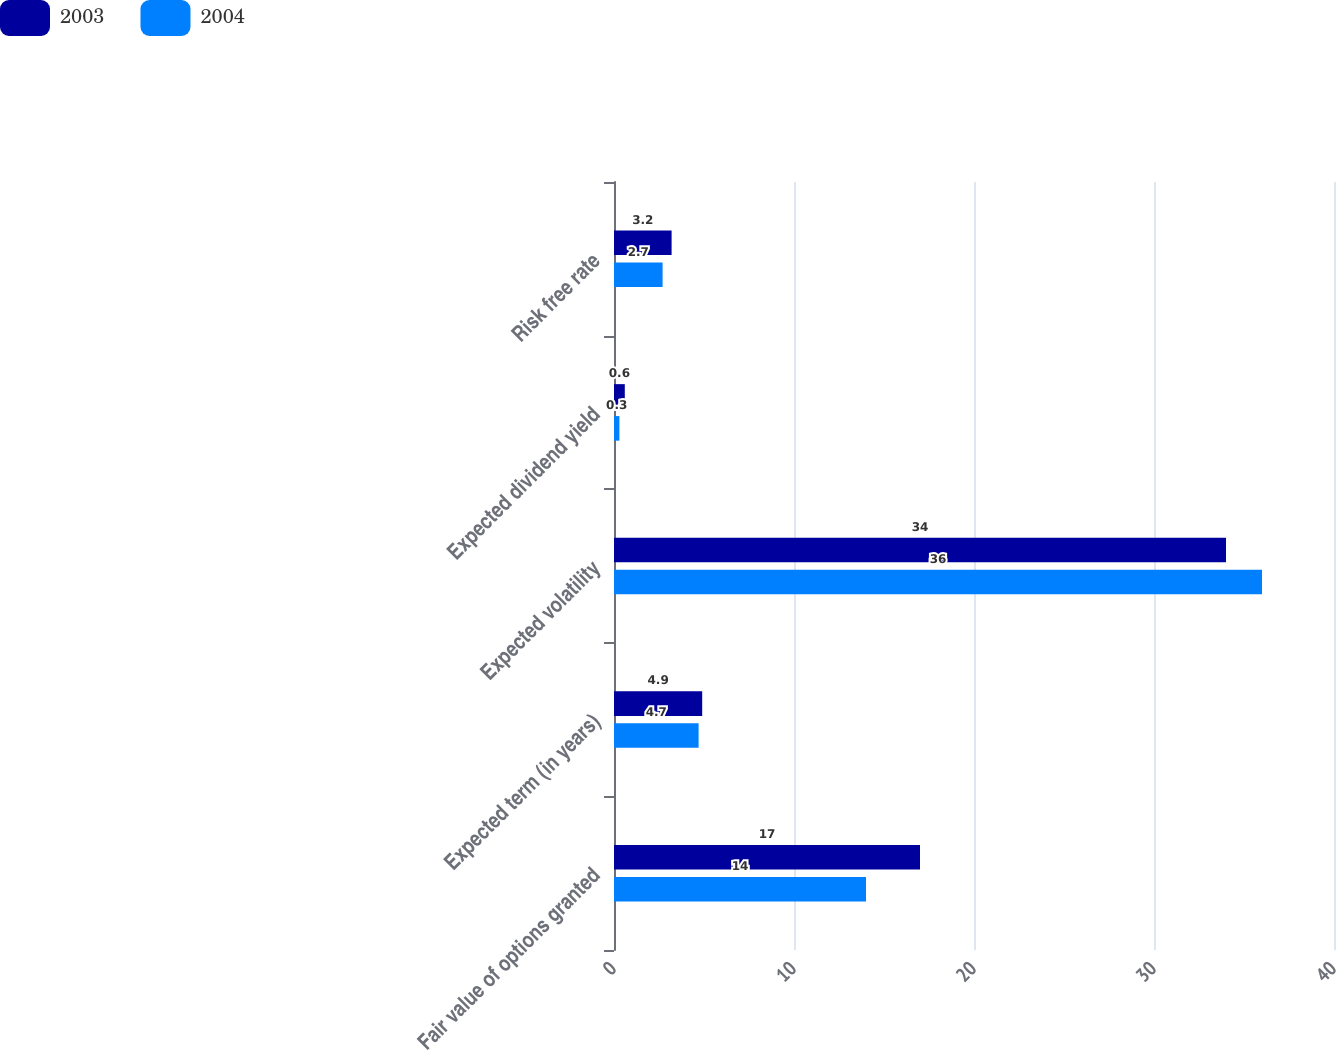Convert chart. <chart><loc_0><loc_0><loc_500><loc_500><stacked_bar_chart><ecel><fcel>Fair value of options granted<fcel>Expected term (in years)<fcel>Expected volatility<fcel>Expected dividend yield<fcel>Risk free rate<nl><fcel>2003<fcel>17<fcel>4.9<fcel>34<fcel>0.6<fcel>3.2<nl><fcel>2004<fcel>14<fcel>4.7<fcel>36<fcel>0.3<fcel>2.7<nl></chart> 